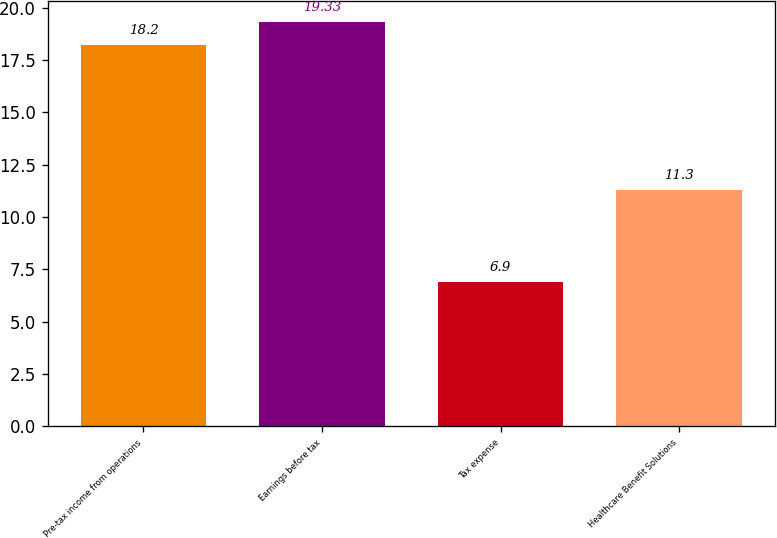Convert chart. <chart><loc_0><loc_0><loc_500><loc_500><bar_chart><fcel>Pre-tax income from operations<fcel>Earnings before tax<fcel>Tax expense<fcel>Healthcare Benefit Solutions<nl><fcel>18.2<fcel>19.33<fcel>6.9<fcel>11.3<nl></chart> 